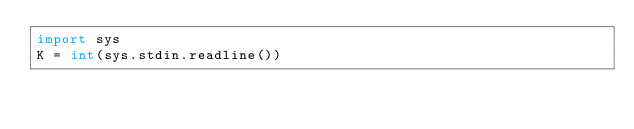Convert code to text. <code><loc_0><loc_0><loc_500><loc_500><_Python_>import sys
K = int(sys.stdin.readline())
</code> 